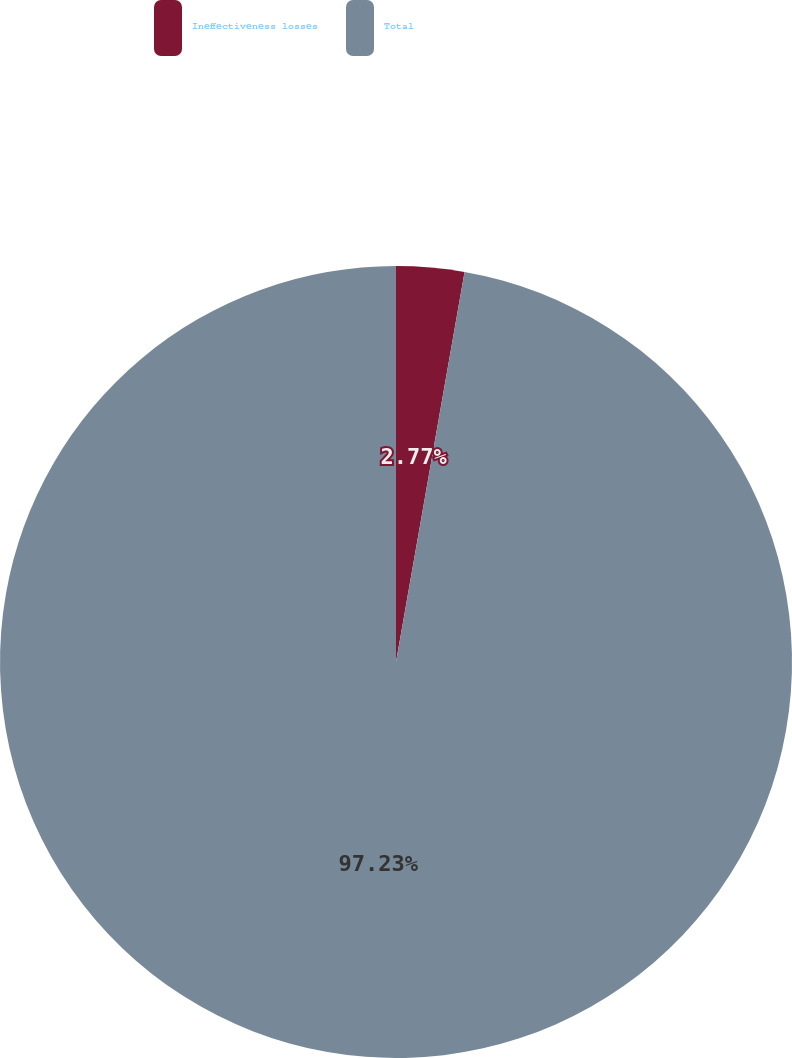Convert chart to OTSL. <chart><loc_0><loc_0><loc_500><loc_500><pie_chart><fcel>Ineffectiveness losses<fcel>Total<nl><fcel>2.77%<fcel>97.23%<nl></chart> 